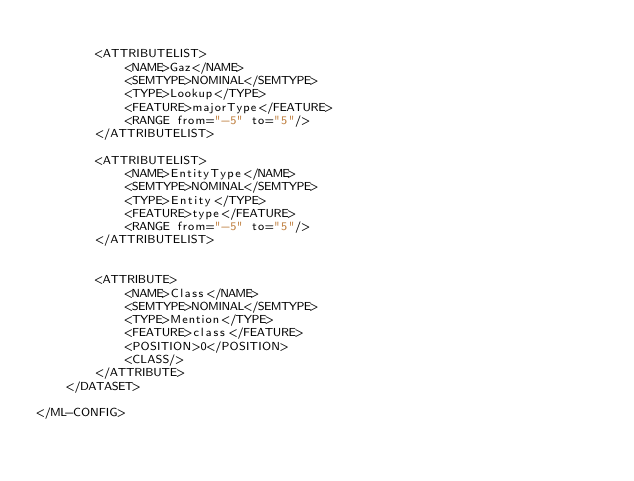Convert code to text. <code><loc_0><loc_0><loc_500><loc_500><_XML_>
		<ATTRIBUTELIST>
			<NAME>Gaz</NAME>
			<SEMTYPE>NOMINAL</SEMTYPE>
			<TYPE>Lookup</TYPE>
			<FEATURE>majorType</FEATURE>
			<RANGE from="-5" to="5"/>
		</ATTRIBUTELIST>

		<ATTRIBUTELIST>
			<NAME>EntityType</NAME>
			<SEMTYPE>NOMINAL</SEMTYPE>
			<TYPE>Entity</TYPE>
			<FEATURE>type</FEATURE>
			<RANGE from="-5" to="5"/>
		</ATTRIBUTELIST>

	
		<ATTRIBUTE>
			<NAME>Class</NAME>
			<SEMTYPE>NOMINAL</SEMTYPE>
			<TYPE>Mention</TYPE>
			<FEATURE>class</FEATURE>
			<POSITION>0</POSITION>
			<CLASS/>
		</ATTRIBUTE>
	</DATASET>

</ML-CONFIG>

</code> 